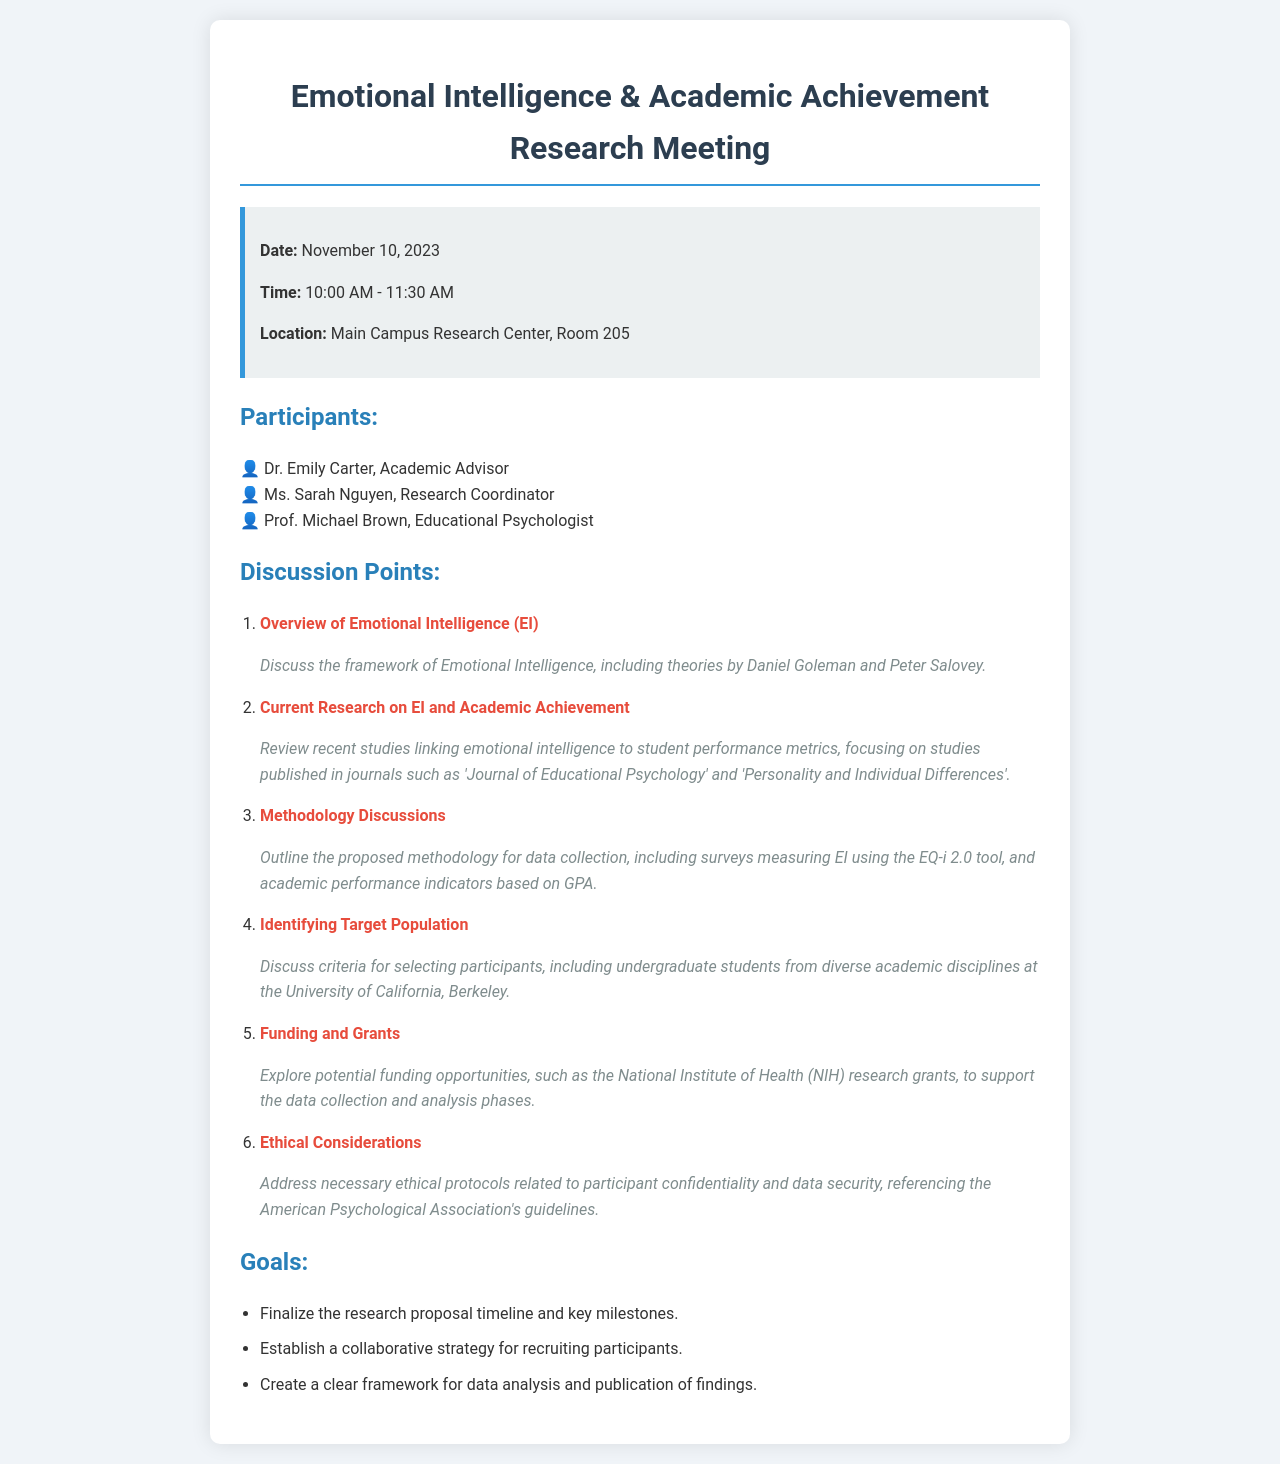What is the date of the meeting? The date of the meeting is mentioned explicitly in the meeting info section of the document.
Answer: November 10, 2023 Who is the Academic Advisor present at the meeting? The document lists the participants including their roles, where the Academic Advisor is specifically named.
Answer: Dr. Emily Carter What time does the meeting start? The start time of the meeting is listed clearly in the meeting information section of the document.
Answer: 10:00 AM What is one of the discussion points regarding ethical considerations? The document outlines the discussion points, specifically mentioning ethical protocols related to participant issues.
Answer: Participant confidentiality What is one goal of the meeting? The goals of the meeting are outlined in a specific section where several objectives are mentioned.
Answer: Finalize the research proposal timeline Which tool is proposed for measuring Emotional Intelligence? The methodology discussion mentions the specific tool proposed for measuring Emotional Intelligence.
Answer: EQ-i 2.0 What type of students are being targeted for the study? The criteria for selecting participants specify a particular group of students.
Answer: Undergraduate students How long is the meeting scheduled to last? The meeting duration can be calculated from the start and end times provided in the document.
Answer: 1 hour 30 minutes 